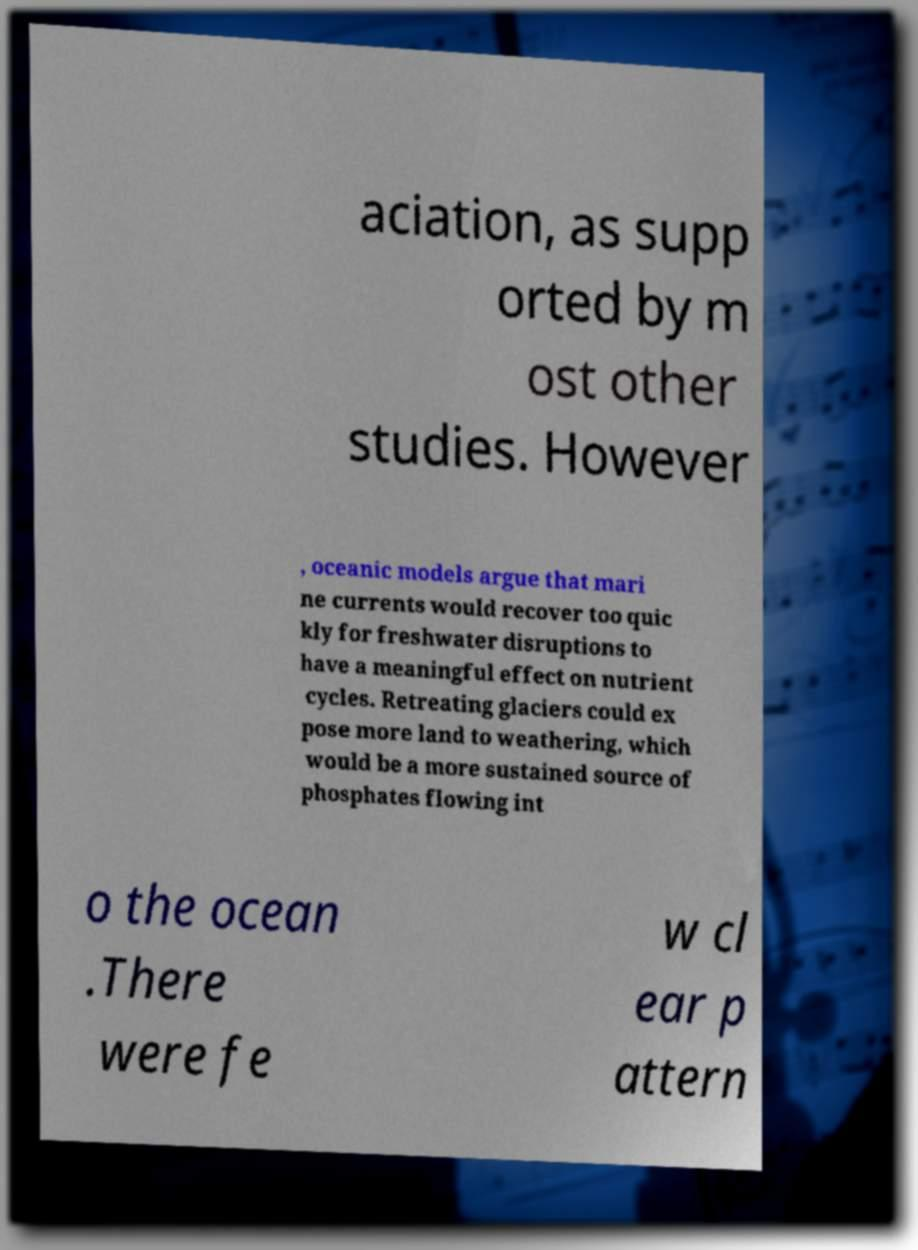There's text embedded in this image that I need extracted. Can you transcribe it verbatim? aciation, as supp orted by m ost other studies. However , oceanic models argue that mari ne currents would recover too quic kly for freshwater disruptions to have a meaningful effect on nutrient cycles. Retreating glaciers could ex pose more land to weathering, which would be a more sustained source of phosphates flowing int o the ocean .There were fe w cl ear p attern 